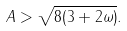<formula> <loc_0><loc_0><loc_500><loc_500>A > \sqrt { 8 ( 3 + 2 \omega ) } .</formula> 